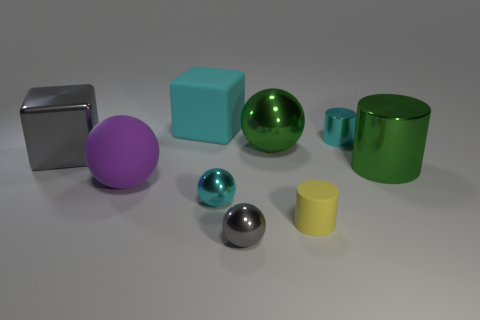What size is the object that is the same color as the large cylinder?
Your answer should be very brief. Large. What number of objects are either cubes or tiny cyan things to the left of the yellow rubber thing?
Make the answer very short. 3. Are there any yellow objects in front of the large block right of the purple rubber object?
Your answer should be compact. Yes. What is the shape of the big matte thing behind the green metal thing that is in front of the ball that is behind the shiny cube?
Give a very brief answer. Cube. The big shiny thing that is both right of the big gray metallic thing and behind the big cylinder is what color?
Your answer should be very brief. Green. The tiny metal object that is behind the big gray metal cube has what shape?
Your answer should be compact. Cylinder. What is the shape of the cyan thing that is made of the same material as the cyan ball?
Offer a very short reply. Cylinder. What number of shiny things are either large gray cubes or large green cylinders?
Ensure brevity in your answer.  2. There is a small cylinder that is in front of the tiny cyan cylinder behind the big metal sphere; what number of green objects are left of it?
Provide a short and direct response. 1. Do the gray object behind the big purple thing and the purple matte ball that is left of the rubber cube have the same size?
Your answer should be compact. Yes. 